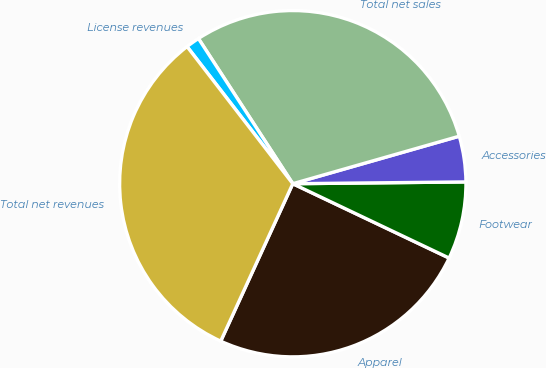Convert chart to OTSL. <chart><loc_0><loc_0><loc_500><loc_500><pie_chart><fcel>Apparel<fcel>Footwear<fcel>Accessories<fcel>Total net sales<fcel>License revenues<fcel>Total net revenues<nl><fcel>24.77%<fcel>7.23%<fcel>4.26%<fcel>29.75%<fcel>1.28%<fcel>32.72%<nl></chart> 